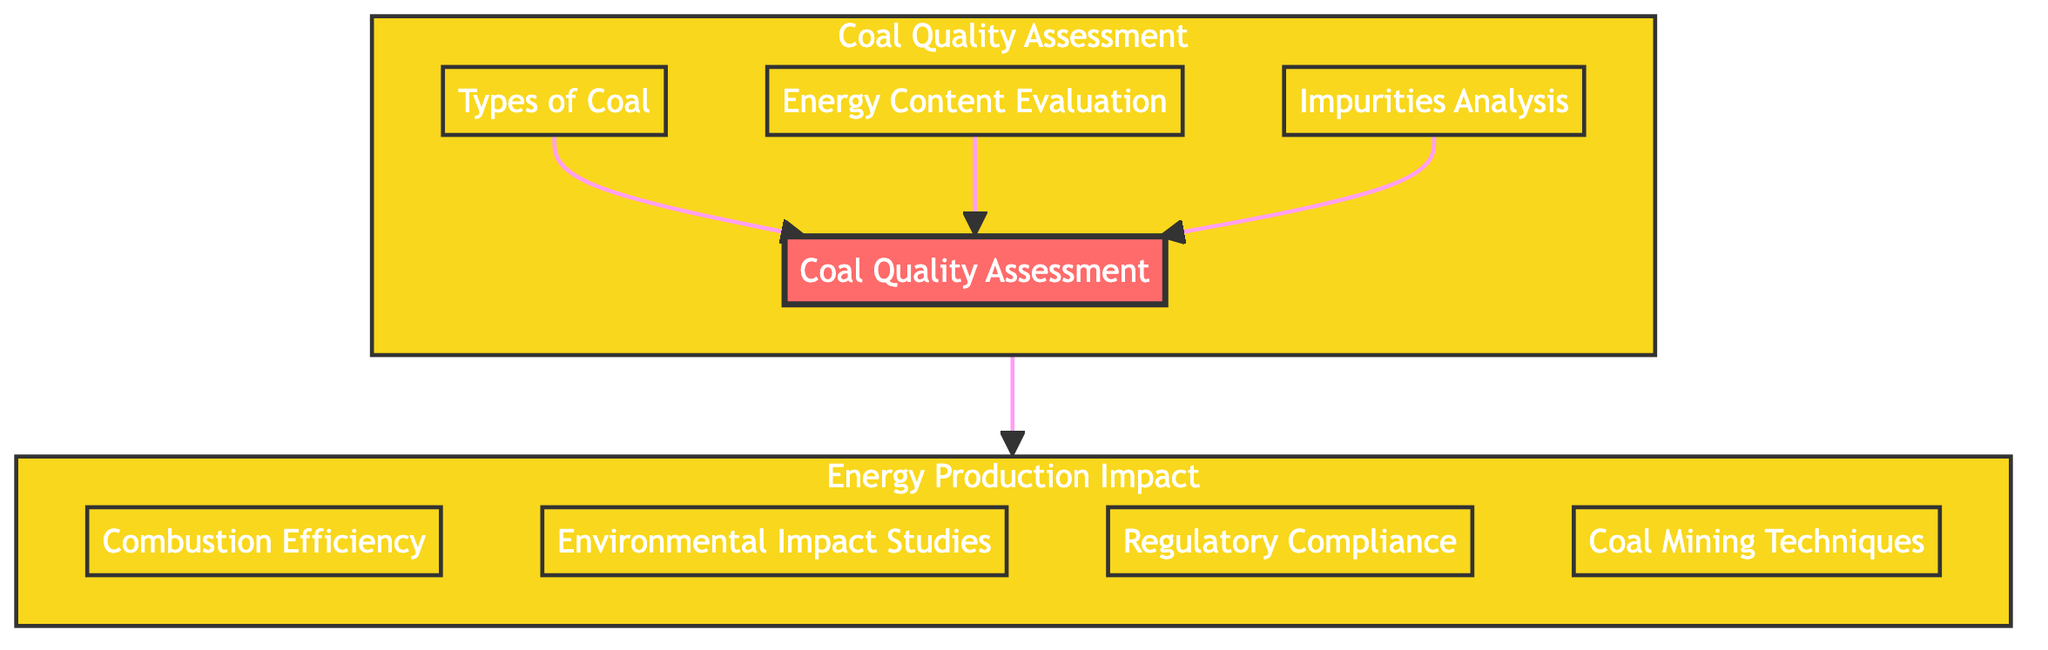What is the main focus of the diagram? The main focus of the diagram is "Analysis of Coal Quality and Impact on Energy Production." This is evident from the two main sections labeled "Coal Quality Assessment" and "Energy Production Impact," which are interconnected.
Answer: Analysis of Coal Quality and Impact on Energy Production How many elements are in the Coal Quality Assessment section? In the "Coal Quality Assessment" section, there are four elements: "Coal Quality Assessment," "Types of Coal," "Energy Content Evaluation," and "Impurities Analysis."
Answer: Four Which element leads to both Energy Content Evaluation and Impurities Analysis? The element "Coal Quality Assessment" leads to both "Energy Content Evaluation" and "Impurities Analysis." This is shown by the direct arrows pointing from "Coal Quality Assessment" to those two elements.
Answer: Coal Quality Assessment What are the two types of assessments conducted in the Energy Production Impact section? The two types of assessments conducted in the "Energy Production Impact" section are "Combustion Efficiency" and "Environmental Impact Studies." These elements are both part of that section as shown in the diagram.
Answer: Combustion Efficiency, Environmental Impact Studies Is there a direct link between "Types of Coal" and any node in the Energy Production Impact section? No, there is no direct link between "Types of Coal" and any node in the "Energy Production Impact" section. The diagram shows that "Types of Coal" is only linked to "Coal Quality Assessment."
Answer: No How do Coal Quality Assessment and Energy Production Impact sections relate to each other? The "Coal Quality Assessment" section feeds into the "Energy Production Impact" section, establishing a connection that indicates the quality of coal affects energy production and its related impacts.
Answer: They are interconnected; coal quality affects energy production Which element is concerned with ensuring compliance with regulations? The element that is concerned with ensuring compliance with regulations is "Regulatory Compliance." It addresses the need for coal production and energy generation to adhere to environmental laws.
Answer: Regulatory Compliance What component is focused on evaluating local ecosystems? The component focused on evaluating local ecosystems is "Environmental Impact Studies." This element specifically deals with the assessment of coal usage effects on the environment.
Answer: Environmental Impact Studies 